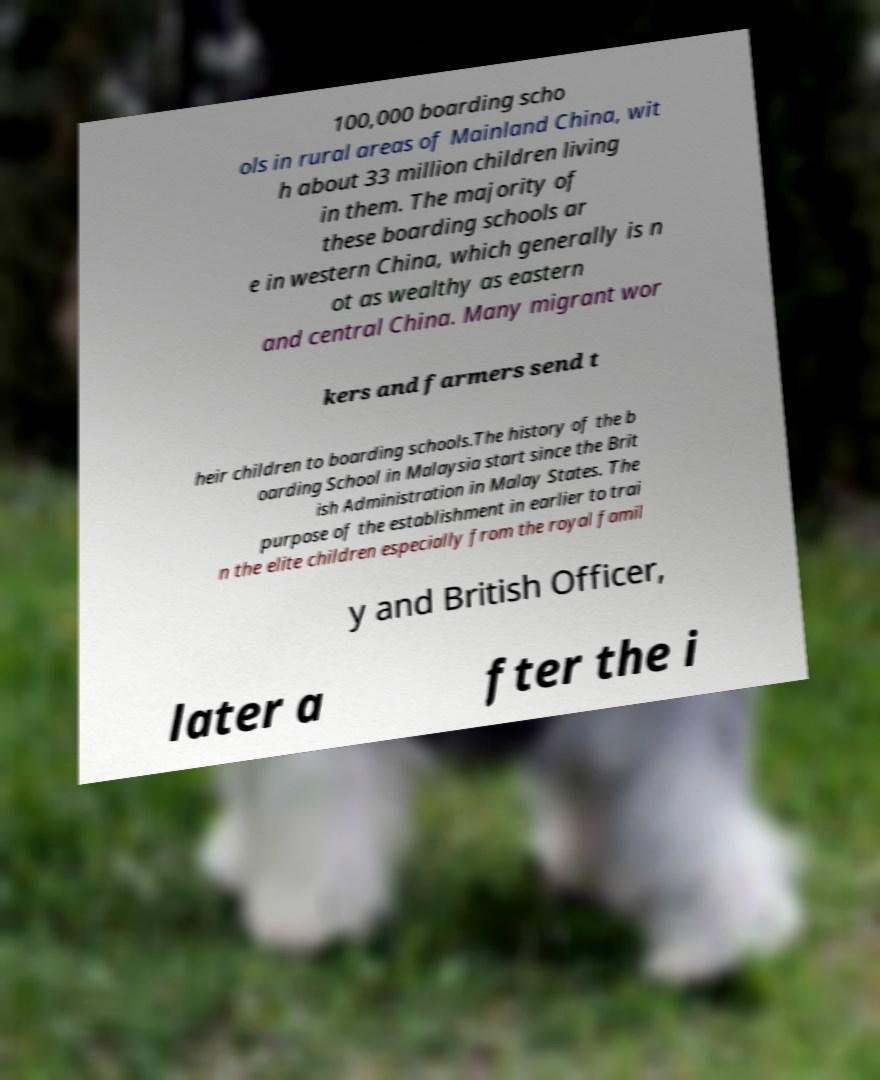There's text embedded in this image that I need extracted. Can you transcribe it verbatim? 100,000 boarding scho ols in rural areas of Mainland China, wit h about 33 million children living in them. The majority of these boarding schools ar e in western China, which generally is n ot as wealthy as eastern and central China. Many migrant wor kers and farmers send t heir children to boarding schools.The history of the b oarding School in Malaysia start since the Brit ish Administration in Malay States. The purpose of the establishment in earlier to trai n the elite children especially from the royal famil y and British Officer, later a fter the i 